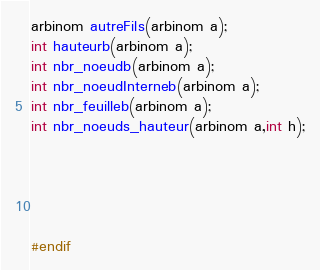<code> <loc_0><loc_0><loc_500><loc_500><_C_>arbinom autreFils(arbinom a);
int hauteurb(arbinom a);
int nbr_noeudb(arbinom a);
int nbr_noeudInterneb(arbinom a);
int nbr_feuilleb(arbinom a);
int nbr_noeuds_hauteur(arbinom a,int h);





#endif

</code> 